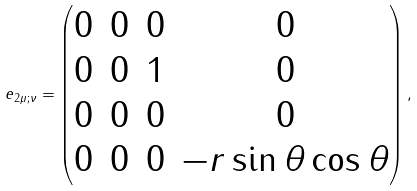Convert formula to latex. <formula><loc_0><loc_0><loc_500><loc_500>e _ { 2 \mu ; \nu } = \begin{pmatrix} 0 & 0 & 0 & 0 \\ 0 & 0 & 1 & 0 \\ 0 & 0 & 0 & 0 \\ 0 & 0 & 0 & - r \sin \theta \cos \theta \end{pmatrix} ,</formula> 